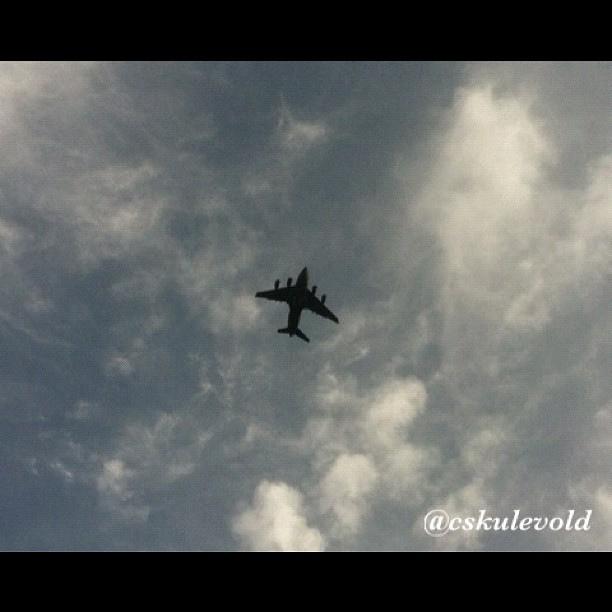What is the person riding?
Be succinct. Airplane. In what direction is the plane traveling?
Concise answer only. Up. Is the plane not working?
Keep it brief. No. What is the shortest word in the bottom right hand corner?
Answer briefly. Cskulevold. How many engines does this plane have?
Quick response, please. 4. IS there water?
Short answer required. No. Is the sky overcast or sunny?
Short answer required. Overcast. What is the black thing?
Keep it brief. Plane. What is in focus?
Answer briefly. Plane. Is the plane landing?
Keep it brief. No. Is this in africa?
Be succinct. No. Is there a building in the picture?
Short answer required. No. Where is the airplane resting?
Keep it brief. Nowhere. Is the plane at an airport?
Be succinct. No. What type of plane is that?
Short answer required. Jet. What is  the bus color?
Quick response, please. No bus. What is the plane doing?
Quick response, please. Flying. Is the plane loading passengers?
Concise answer only. No. Are there clouds in the sky?
Write a very short answer. Yes. What two surfaces are shown?
Concise answer only. Sky. Is this a jet or propeller plane?
Quick response, please. Jet. What is the magazine named?
Be succinct. Cskulevold. What is the picture capturing?
Be succinct. Plane. Is this playing landing?
Be succinct. No. What color is dominant?
Quick response, please. Gray. Is it a sunny day?
Short answer required. Yes. Is the plane a jet plane?
Write a very short answer. Yes. Is this a crow?
Quick response, please. No. How does the plane fly?
Keep it brief. In air. What does the name in the lower right hand corner signify?
Short answer required. Photographer. What else is in the sky,besides kites?
Concise answer only. Plane. Can you see water?
Quick response, please. No. How many trees are in the background?
Keep it brief. 0. How many engines does the airplane have?
Quick response, please. 4. What is the Black bar on the bottom of the screen?
Quick response, please. Frame. What is in the air?
Answer briefly. Plane. Is there a sailboat in the photo?
Answer briefly. No. What is the notation on the bottom of the picture?
Give a very brief answer. @cskulevold. 